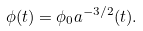Convert formula to latex. <formula><loc_0><loc_0><loc_500><loc_500>\phi ( t ) = \phi _ { 0 } a ^ { - 3 / 2 } ( t ) .</formula> 